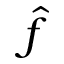Convert formula to latex. <formula><loc_0><loc_0><loc_500><loc_500>\hat { f }</formula> 